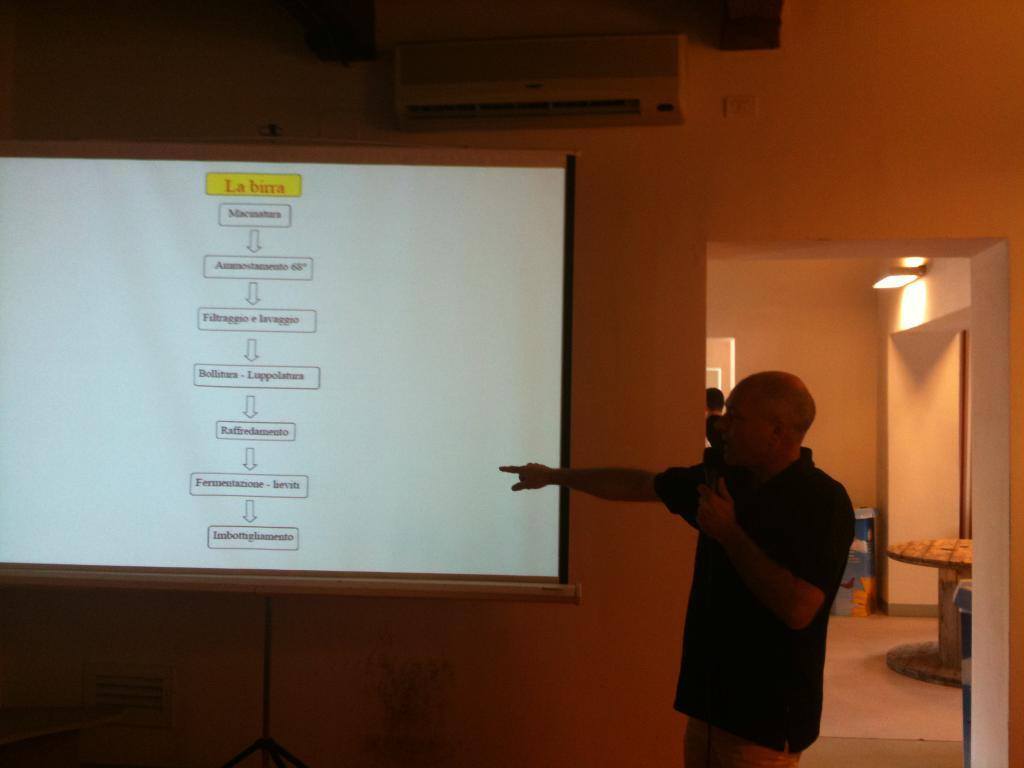<image>
Provide a brief description of the given image. A man points at a screen that has the term "la birra" at the top. 